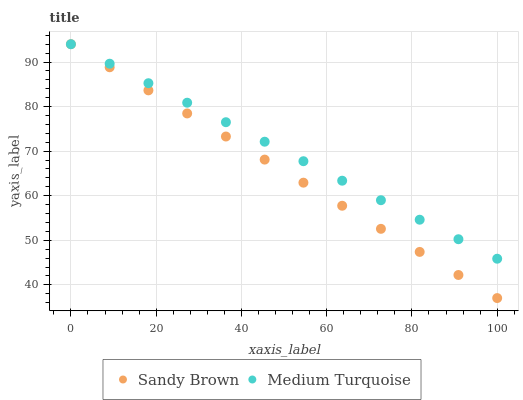Does Sandy Brown have the minimum area under the curve?
Answer yes or no. Yes. Does Medium Turquoise have the maximum area under the curve?
Answer yes or no. Yes. Does Medium Turquoise have the minimum area under the curve?
Answer yes or no. No. Is Sandy Brown the smoothest?
Answer yes or no. Yes. Is Medium Turquoise the roughest?
Answer yes or no. Yes. Is Medium Turquoise the smoothest?
Answer yes or no. No. Does Sandy Brown have the lowest value?
Answer yes or no. Yes. Does Medium Turquoise have the lowest value?
Answer yes or no. No. Does Medium Turquoise have the highest value?
Answer yes or no. Yes. Does Sandy Brown intersect Medium Turquoise?
Answer yes or no. Yes. Is Sandy Brown less than Medium Turquoise?
Answer yes or no. No. Is Sandy Brown greater than Medium Turquoise?
Answer yes or no. No. 